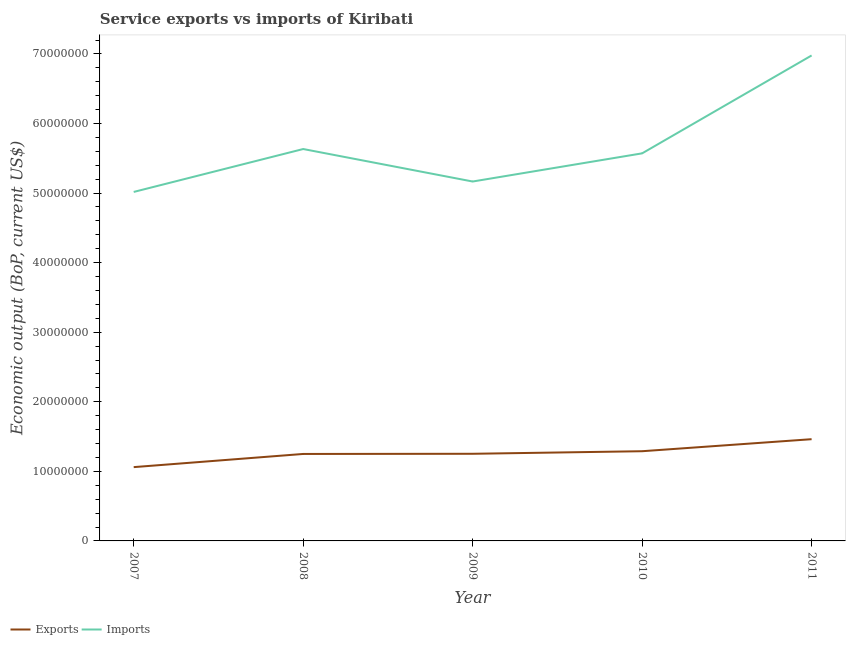How many different coloured lines are there?
Your answer should be very brief. 2. Does the line corresponding to amount of service exports intersect with the line corresponding to amount of service imports?
Your answer should be compact. No. Is the number of lines equal to the number of legend labels?
Your answer should be very brief. Yes. What is the amount of service exports in 2008?
Offer a terse response. 1.25e+07. Across all years, what is the maximum amount of service exports?
Your answer should be compact. 1.46e+07. Across all years, what is the minimum amount of service exports?
Provide a short and direct response. 1.06e+07. What is the total amount of service exports in the graph?
Provide a short and direct response. 6.31e+07. What is the difference between the amount of service exports in 2007 and that in 2009?
Offer a terse response. -1.92e+06. What is the difference between the amount of service imports in 2011 and the amount of service exports in 2008?
Give a very brief answer. 5.73e+07. What is the average amount of service imports per year?
Give a very brief answer. 5.67e+07. In the year 2010, what is the difference between the amount of service exports and amount of service imports?
Offer a terse response. -4.28e+07. In how many years, is the amount of service imports greater than 44000000 US$?
Your response must be concise. 5. What is the ratio of the amount of service imports in 2008 to that in 2010?
Provide a short and direct response. 1.01. What is the difference between the highest and the second highest amount of service imports?
Offer a terse response. 1.34e+07. What is the difference between the highest and the lowest amount of service imports?
Your response must be concise. 1.96e+07. Is the sum of the amount of service imports in 2007 and 2011 greater than the maximum amount of service exports across all years?
Provide a succinct answer. Yes. Is the amount of service imports strictly less than the amount of service exports over the years?
Offer a very short reply. No. Are the values on the major ticks of Y-axis written in scientific E-notation?
Provide a succinct answer. No. Does the graph contain any zero values?
Keep it short and to the point. No. Does the graph contain grids?
Give a very brief answer. No. How are the legend labels stacked?
Make the answer very short. Horizontal. What is the title of the graph?
Give a very brief answer. Service exports vs imports of Kiribati. What is the label or title of the X-axis?
Provide a succinct answer. Year. What is the label or title of the Y-axis?
Offer a terse response. Economic output (BoP, current US$). What is the Economic output (BoP, current US$) of Exports in 2007?
Provide a succinct answer. 1.06e+07. What is the Economic output (BoP, current US$) in Imports in 2007?
Provide a succinct answer. 5.02e+07. What is the Economic output (BoP, current US$) of Exports in 2008?
Give a very brief answer. 1.25e+07. What is the Economic output (BoP, current US$) of Imports in 2008?
Keep it short and to the point. 5.63e+07. What is the Economic output (BoP, current US$) in Exports in 2009?
Keep it short and to the point. 1.25e+07. What is the Economic output (BoP, current US$) of Imports in 2009?
Your answer should be very brief. 5.17e+07. What is the Economic output (BoP, current US$) of Exports in 2010?
Provide a succinct answer. 1.29e+07. What is the Economic output (BoP, current US$) in Imports in 2010?
Ensure brevity in your answer.  5.57e+07. What is the Economic output (BoP, current US$) of Exports in 2011?
Make the answer very short. 1.46e+07. What is the Economic output (BoP, current US$) of Imports in 2011?
Give a very brief answer. 6.98e+07. Across all years, what is the maximum Economic output (BoP, current US$) of Exports?
Offer a terse response. 1.46e+07. Across all years, what is the maximum Economic output (BoP, current US$) in Imports?
Your response must be concise. 6.98e+07. Across all years, what is the minimum Economic output (BoP, current US$) of Exports?
Provide a short and direct response. 1.06e+07. Across all years, what is the minimum Economic output (BoP, current US$) in Imports?
Provide a short and direct response. 5.02e+07. What is the total Economic output (BoP, current US$) of Exports in the graph?
Keep it short and to the point. 6.31e+07. What is the total Economic output (BoP, current US$) of Imports in the graph?
Offer a terse response. 2.84e+08. What is the difference between the Economic output (BoP, current US$) in Exports in 2007 and that in 2008?
Provide a short and direct response. -1.89e+06. What is the difference between the Economic output (BoP, current US$) of Imports in 2007 and that in 2008?
Offer a very short reply. -6.17e+06. What is the difference between the Economic output (BoP, current US$) in Exports in 2007 and that in 2009?
Offer a very short reply. -1.92e+06. What is the difference between the Economic output (BoP, current US$) of Imports in 2007 and that in 2009?
Provide a short and direct response. -1.50e+06. What is the difference between the Economic output (BoP, current US$) in Exports in 2007 and that in 2010?
Ensure brevity in your answer.  -2.29e+06. What is the difference between the Economic output (BoP, current US$) in Imports in 2007 and that in 2010?
Offer a very short reply. -5.55e+06. What is the difference between the Economic output (BoP, current US$) in Exports in 2007 and that in 2011?
Offer a terse response. -4.02e+06. What is the difference between the Economic output (BoP, current US$) in Imports in 2007 and that in 2011?
Provide a succinct answer. -1.96e+07. What is the difference between the Economic output (BoP, current US$) in Exports in 2008 and that in 2009?
Your answer should be compact. -2.52e+04. What is the difference between the Economic output (BoP, current US$) of Imports in 2008 and that in 2009?
Your answer should be compact. 4.67e+06. What is the difference between the Economic output (BoP, current US$) of Exports in 2008 and that in 2010?
Your response must be concise. -3.94e+05. What is the difference between the Economic output (BoP, current US$) in Imports in 2008 and that in 2010?
Make the answer very short. 6.22e+05. What is the difference between the Economic output (BoP, current US$) in Exports in 2008 and that in 2011?
Offer a very short reply. -2.12e+06. What is the difference between the Economic output (BoP, current US$) of Imports in 2008 and that in 2011?
Give a very brief answer. -1.34e+07. What is the difference between the Economic output (BoP, current US$) of Exports in 2009 and that in 2010?
Your answer should be very brief. -3.68e+05. What is the difference between the Economic output (BoP, current US$) in Imports in 2009 and that in 2010?
Offer a terse response. -4.05e+06. What is the difference between the Economic output (BoP, current US$) of Exports in 2009 and that in 2011?
Keep it short and to the point. -2.10e+06. What is the difference between the Economic output (BoP, current US$) of Imports in 2009 and that in 2011?
Your response must be concise. -1.81e+07. What is the difference between the Economic output (BoP, current US$) of Exports in 2010 and that in 2011?
Provide a short and direct response. -1.73e+06. What is the difference between the Economic output (BoP, current US$) of Imports in 2010 and that in 2011?
Ensure brevity in your answer.  -1.41e+07. What is the difference between the Economic output (BoP, current US$) of Exports in 2007 and the Economic output (BoP, current US$) of Imports in 2008?
Your answer should be compact. -4.57e+07. What is the difference between the Economic output (BoP, current US$) in Exports in 2007 and the Economic output (BoP, current US$) in Imports in 2009?
Provide a succinct answer. -4.11e+07. What is the difference between the Economic output (BoP, current US$) of Exports in 2007 and the Economic output (BoP, current US$) of Imports in 2010?
Offer a very short reply. -4.51e+07. What is the difference between the Economic output (BoP, current US$) in Exports in 2007 and the Economic output (BoP, current US$) in Imports in 2011?
Offer a very short reply. -5.92e+07. What is the difference between the Economic output (BoP, current US$) of Exports in 2008 and the Economic output (BoP, current US$) of Imports in 2009?
Keep it short and to the point. -3.92e+07. What is the difference between the Economic output (BoP, current US$) of Exports in 2008 and the Economic output (BoP, current US$) of Imports in 2010?
Offer a very short reply. -4.32e+07. What is the difference between the Economic output (BoP, current US$) of Exports in 2008 and the Economic output (BoP, current US$) of Imports in 2011?
Offer a terse response. -5.73e+07. What is the difference between the Economic output (BoP, current US$) in Exports in 2009 and the Economic output (BoP, current US$) in Imports in 2010?
Give a very brief answer. -4.32e+07. What is the difference between the Economic output (BoP, current US$) in Exports in 2009 and the Economic output (BoP, current US$) in Imports in 2011?
Keep it short and to the point. -5.73e+07. What is the difference between the Economic output (BoP, current US$) of Exports in 2010 and the Economic output (BoP, current US$) of Imports in 2011?
Your response must be concise. -5.69e+07. What is the average Economic output (BoP, current US$) of Exports per year?
Provide a succinct answer. 1.26e+07. What is the average Economic output (BoP, current US$) of Imports per year?
Offer a very short reply. 5.67e+07. In the year 2007, what is the difference between the Economic output (BoP, current US$) in Exports and Economic output (BoP, current US$) in Imports?
Keep it short and to the point. -3.96e+07. In the year 2008, what is the difference between the Economic output (BoP, current US$) in Exports and Economic output (BoP, current US$) in Imports?
Provide a succinct answer. -4.38e+07. In the year 2009, what is the difference between the Economic output (BoP, current US$) of Exports and Economic output (BoP, current US$) of Imports?
Offer a very short reply. -3.91e+07. In the year 2010, what is the difference between the Economic output (BoP, current US$) in Exports and Economic output (BoP, current US$) in Imports?
Offer a very short reply. -4.28e+07. In the year 2011, what is the difference between the Economic output (BoP, current US$) of Exports and Economic output (BoP, current US$) of Imports?
Keep it short and to the point. -5.52e+07. What is the ratio of the Economic output (BoP, current US$) of Exports in 2007 to that in 2008?
Offer a terse response. 0.85. What is the ratio of the Economic output (BoP, current US$) in Imports in 2007 to that in 2008?
Provide a succinct answer. 0.89. What is the ratio of the Economic output (BoP, current US$) in Exports in 2007 to that in 2009?
Offer a terse response. 0.85. What is the ratio of the Economic output (BoP, current US$) in Exports in 2007 to that in 2010?
Offer a very short reply. 0.82. What is the ratio of the Economic output (BoP, current US$) in Imports in 2007 to that in 2010?
Your answer should be compact. 0.9. What is the ratio of the Economic output (BoP, current US$) of Exports in 2007 to that in 2011?
Make the answer very short. 0.73. What is the ratio of the Economic output (BoP, current US$) in Imports in 2007 to that in 2011?
Give a very brief answer. 0.72. What is the ratio of the Economic output (BoP, current US$) in Exports in 2008 to that in 2009?
Your response must be concise. 1. What is the ratio of the Economic output (BoP, current US$) of Imports in 2008 to that in 2009?
Provide a succinct answer. 1.09. What is the ratio of the Economic output (BoP, current US$) of Exports in 2008 to that in 2010?
Offer a terse response. 0.97. What is the ratio of the Economic output (BoP, current US$) in Imports in 2008 to that in 2010?
Ensure brevity in your answer.  1.01. What is the ratio of the Economic output (BoP, current US$) of Exports in 2008 to that in 2011?
Provide a short and direct response. 0.85. What is the ratio of the Economic output (BoP, current US$) of Imports in 2008 to that in 2011?
Provide a succinct answer. 0.81. What is the ratio of the Economic output (BoP, current US$) in Exports in 2009 to that in 2010?
Provide a short and direct response. 0.97. What is the ratio of the Economic output (BoP, current US$) of Imports in 2009 to that in 2010?
Offer a terse response. 0.93. What is the ratio of the Economic output (BoP, current US$) in Exports in 2009 to that in 2011?
Give a very brief answer. 0.86. What is the ratio of the Economic output (BoP, current US$) in Imports in 2009 to that in 2011?
Provide a short and direct response. 0.74. What is the ratio of the Economic output (BoP, current US$) in Exports in 2010 to that in 2011?
Offer a very short reply. 0.88. What is the ratio of the Economic output (BoP, current US$) in Imports in 2010 to that in 2011?
Ensure brevity in your answer.  0.8. What is the difference between the highest and the second highest Economic output (BoP, current US$) in Exports?
Offer a very short reply. 1.73e+06. What is the difference between the highest and the second highest Economic output (BoP, current US$) of Imports?
Your answer should be very brief. 1.34e+07. What is the difference between the highest and the lowest Economic output (BoP, current US$) in Exports?
Your answer should be compact. 4.02e+06. What is the difference between the highest and the lowest Economic output (BoP, current US$) in Imports?
Make the answer very short. 1.96e+07. 